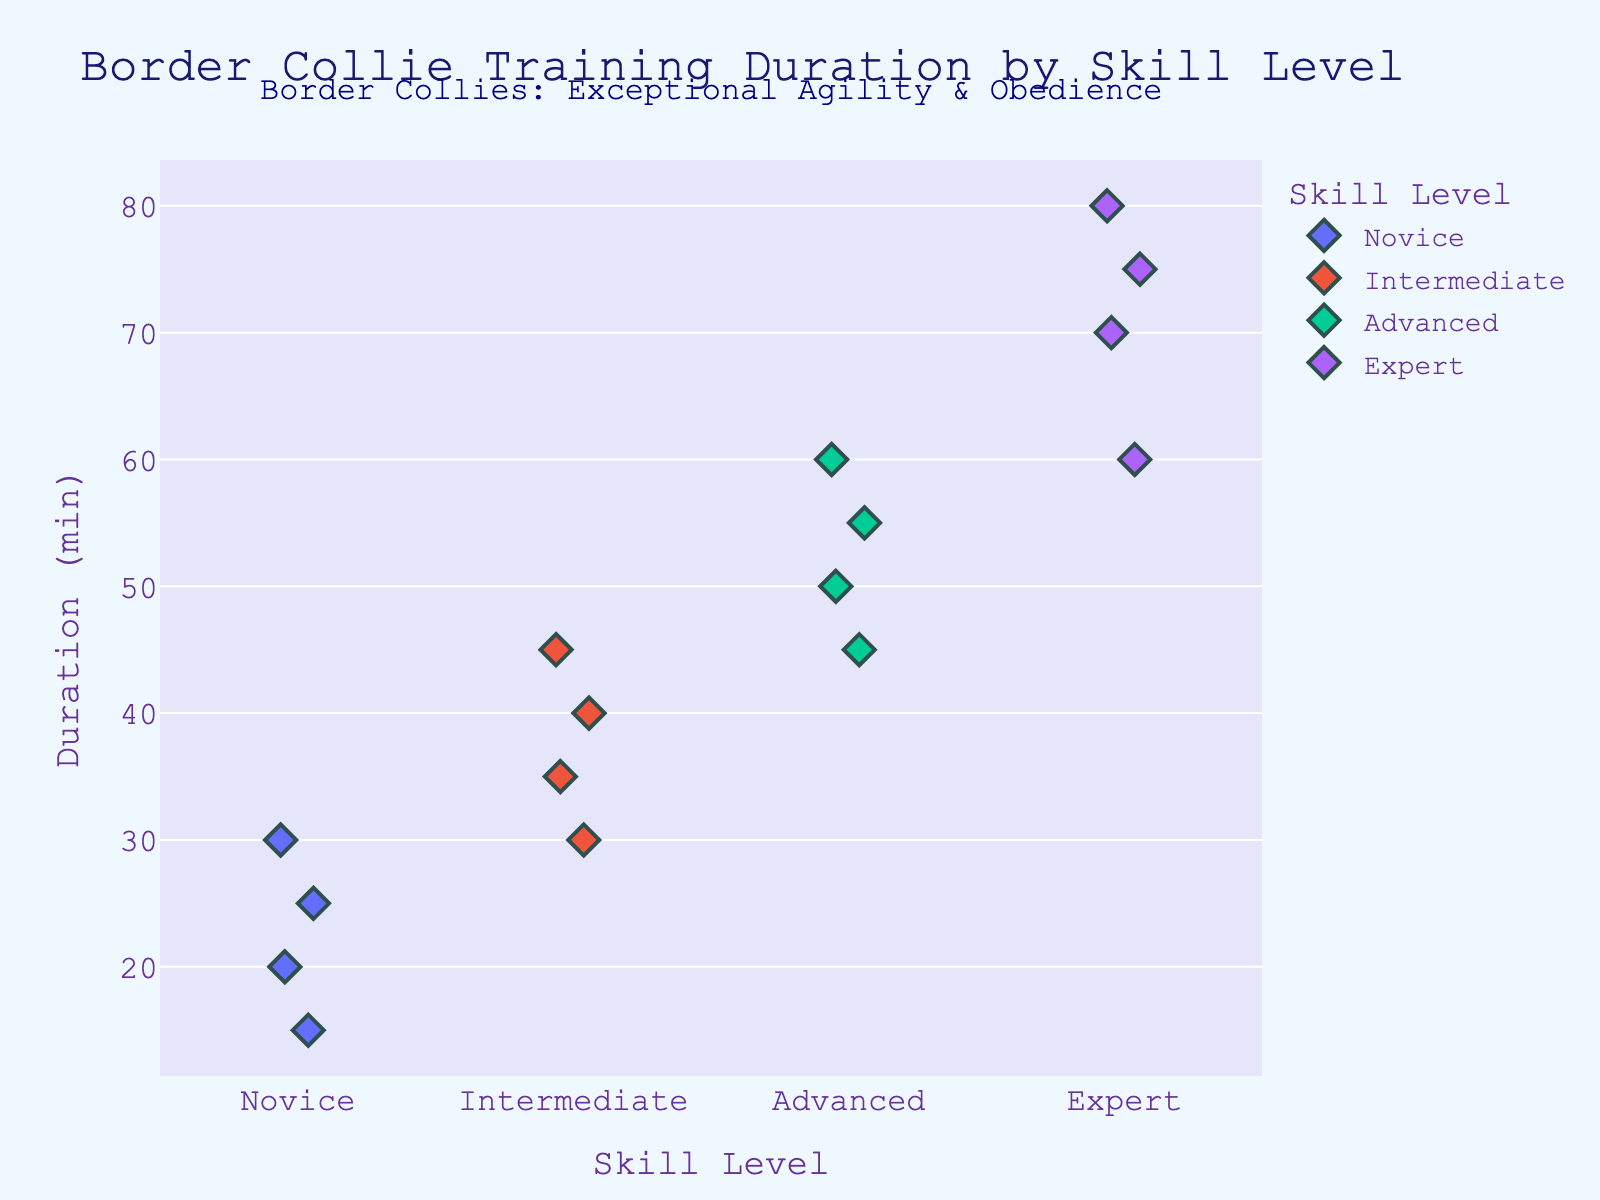What is the title of the plot? The title of the plot is usually displayed at the top of the figure and provides a summary of what the plot represents. In this case, we should look at the top to find "Border Collie Training Duration by Skill Level".
Answer: Border Collie Training Duration by Skill Level How many skill levels are displayed in the plot? We should count the number of different categories (skill levels) represented on the x-axis of the plot. We see "Novice," "Intermediate," "Advanced," and "Expert".
Answer: 4 What is the range of training durations for Novice level? To find the range, we look at the minimum and maximum durations for the Novice level on the y-axis. The lowest duration is 15 minutes, and the highest is 30 minutes.
Answer: 15-30 minutes Which skill level has the highest individual training duration? Look at the topmost data points for each skill level on the y-axis. The highest point appears under the Expert category, which is 80 minutes.
Answer: Expert How do the training durations for Intermediate and Advanced levels compare? Compare the y-values of the data points for Intermediate and Advanced levels. Intermediate ranges from 30-45 minutes, while Advanced ranges from 45-60 minutes. Thus, Advanced training durations are generally longer.
Answer: Advanced durations are longer What is the average training duration for the Expert level? Identify the data points for the Expert level: 60, 70, 75, 80. Compute the average: (60 + 70 + 75 + 80) / 4 = 71.25.
Answer: 71.25 minutes How many data points are there for each skill level? Count the number of points (diamonds) within each skill level category on the x-axis. Each category has 4 data points.
Answer: 4 points per skill level What is the median training duration for the Advanced skill level? The data points for Advanced are 45, 50, 55, and 60. The median is the middle value for an even number of points, which is (50 + 55) / 2 = 52.5.
Answer: 52.5 minutes Which skill level category has the smallest spread of training durations? Calculate the range (max - min) for each skill level. Novice: 30-15=15, Intermediate: 45-30=15, Advanced: 60-45=15, Expert: 80-60=20. All except Expert have a spread of 15.
Answer: Novice, Intermediate, Advanced What visual elements indicate the different skill levels? Inspect the visual markers. The categories are differentiated by colors and labels on the x-axis.
Answer: Colors and labels on the x-axis 